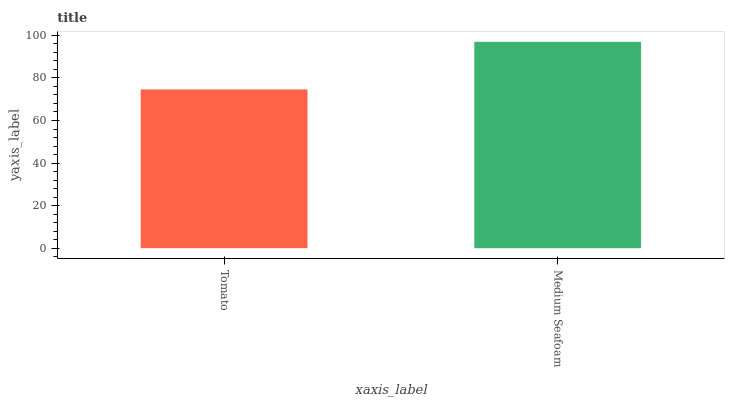Is Medium Seafoam the minimum?
Answer yes or no. No. Is Medium Seafoam greater than Tomato?
Answer yes or no. Yes. Is Tomato less than Medium Seafoam?
Answer yes or no. Yes. Is Tomato greater than Medium Seafoam?
Answer yes or no. No. Is Medium Seafoam less than Tomato?
Answer yes or no. No. Is Medium Seafoam the high median?
Answer yes or no. Yes. Is Tomato the low median?
Answer yes or no. Yes. Is Tomato the high median?
Answer yes or no. No. Is Medium Seafoam the low median?
Answer yes or no. No. 